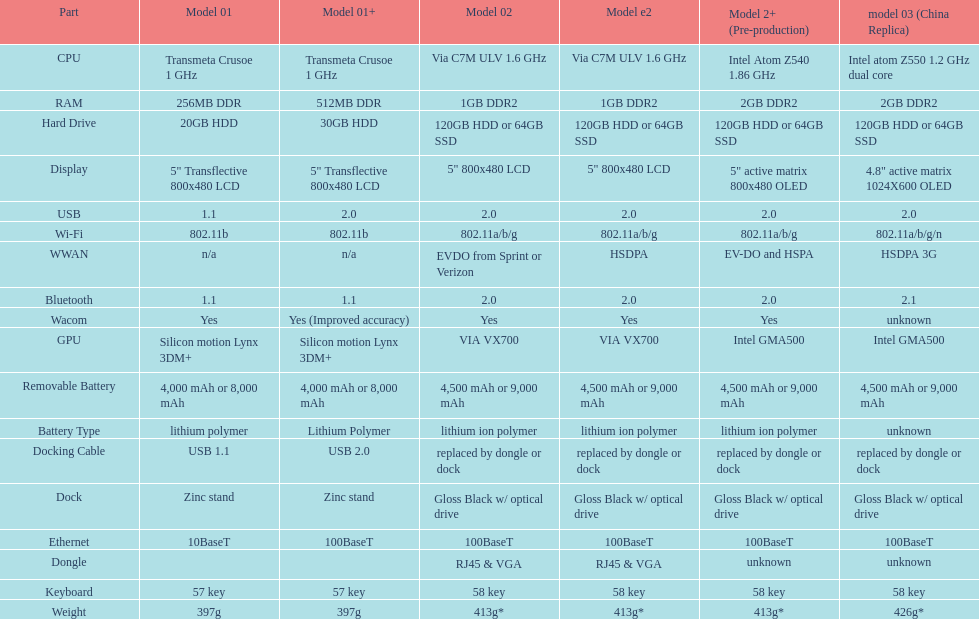What is the component before usb? Display. 